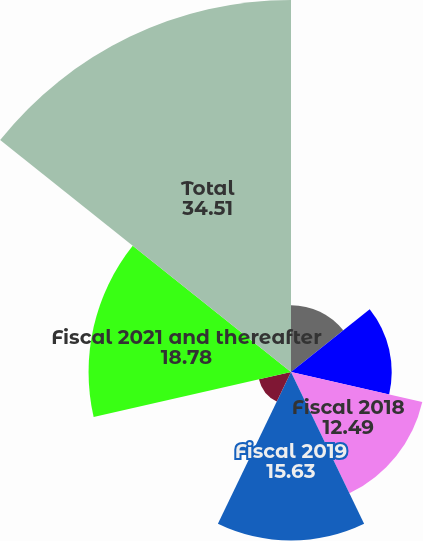Convert chart. <chart><loc_0><loc_0><loc_500><loc_500><pie_chart><fcel>Fiscal 2016<fcel>Fiscal 2017<fcel>Fiscal 2018<fcel>Fiscal 2019<fcel>Fiscal 2020<fcel>Fiscal 2021 and thereafter<fcel>Total<nl><fcel>6.2%<fcel>9.34%<fcel>12.49%<fcel>15.63%<fcel>3.05%<fcel>18.78%<fcel>34.51%<nl></chart> 